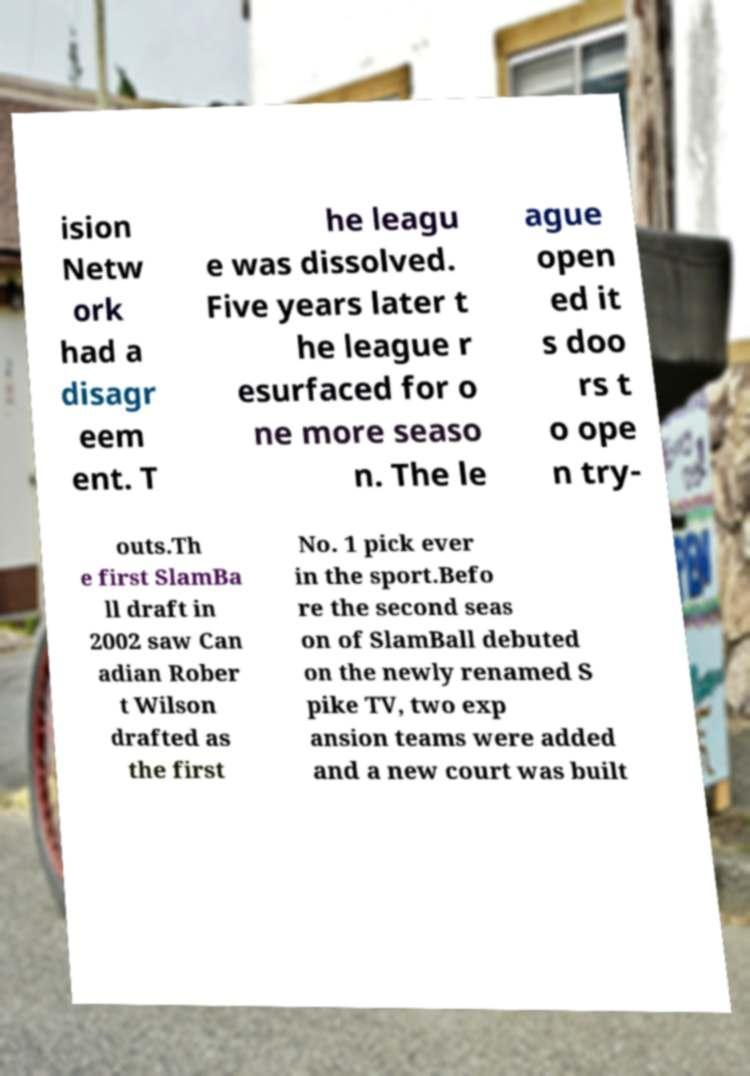I need the written content from this picture converted into text. Can you do that? ision Netw ork had a disagr eem ent. T he leagu e was dissolved. Five years later t he league r esurfaced for o ne more seaso n. The le ague open ed it s doo rs t o ope n try- outs.Th e first SlamBa ll draft in 2002 saw Can adian Rober t Wilson drafted as the first No. 1 pick ever in the sport.Befo re the second seas on of SlamBall debuted on the newly renamed S pike TV, two exp ansion teams were added and a new court was built 